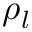Convert formula to latex. <formula><loc_0><loc_0><loc_500><loc_500>\rho _ { l }</formula> 